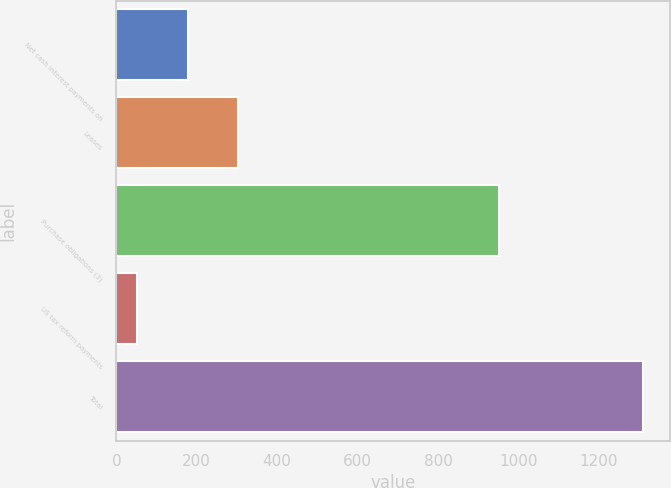Convert chart. <chart><loc_0><loc_0><loc_500><loc_500><bar_chart><fcel>Net cash interest payments on<fcel>Leases<fcel>Purchase obligations (3)<fcel>US tax reform payments<fcel>Total<nl><fcel>177.9<fcel>303.8<fcel>952<fcel>52<fcel>1311<nl></chart> 